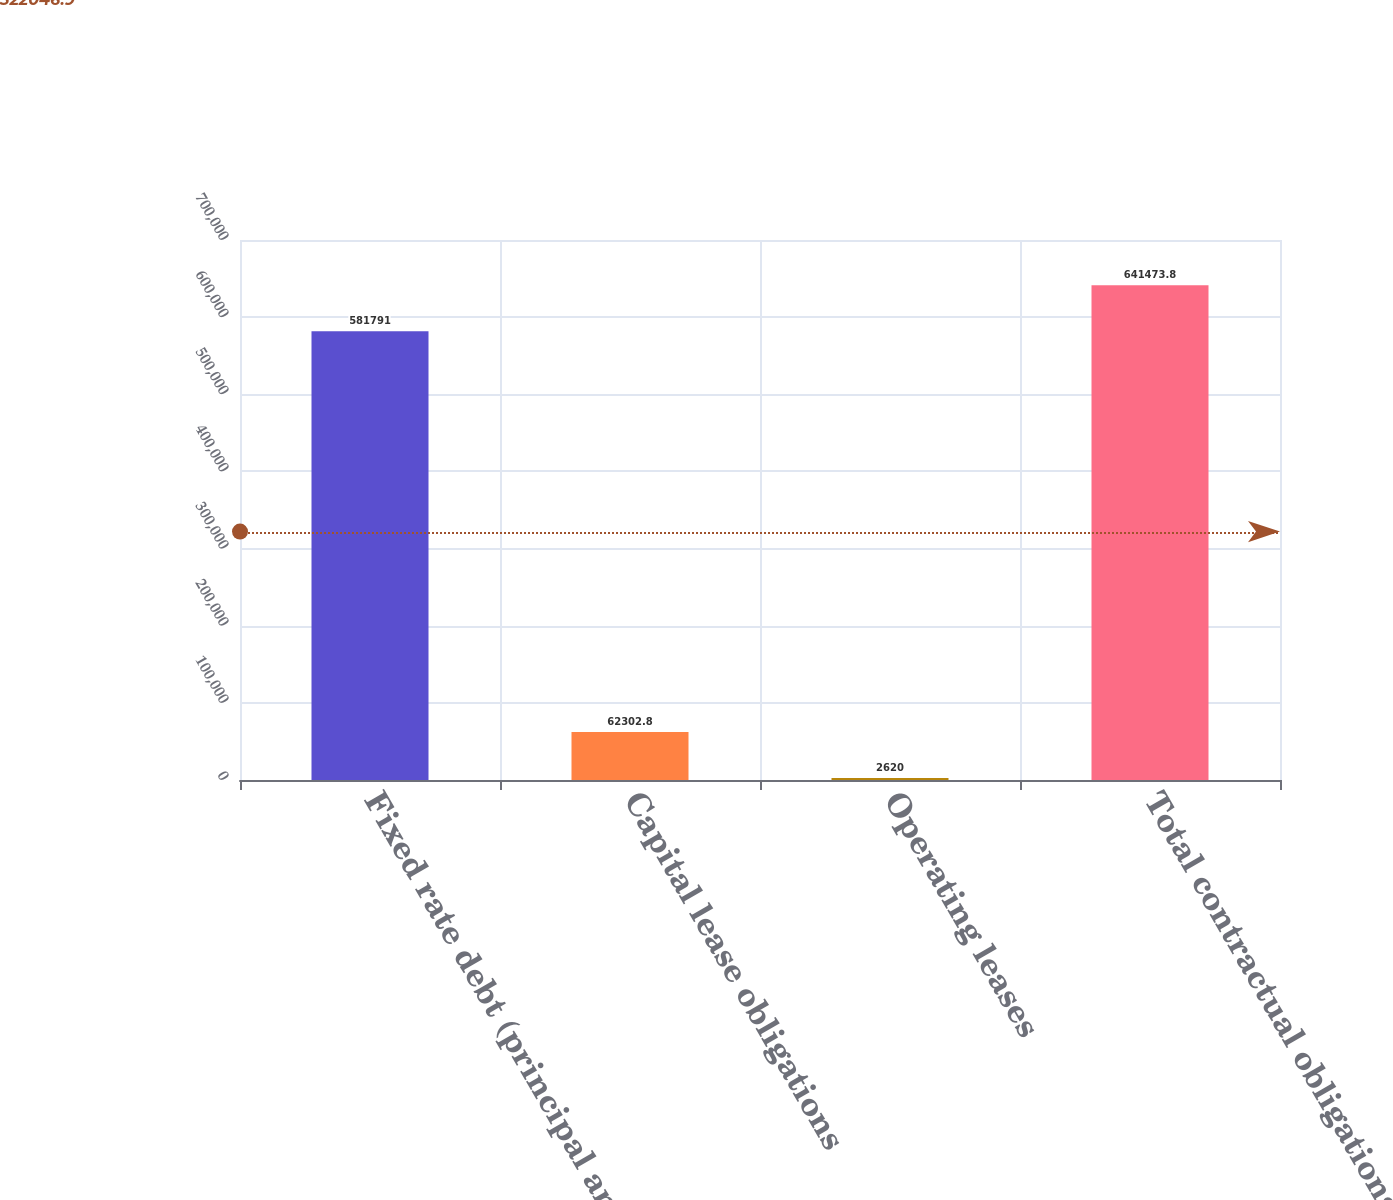Convert chart. <chart><loc_0><loc_0><loc_500><loc_500><bar_chart><fcel>Fixed rate debt (principal and<fcel>Capital lease obligations<fcel>Operating leases<fcel>Total contractual obligations<nl><fcel>581791<fcel>62302.8<fcel>2620<fcel>641474<nl></chart> 